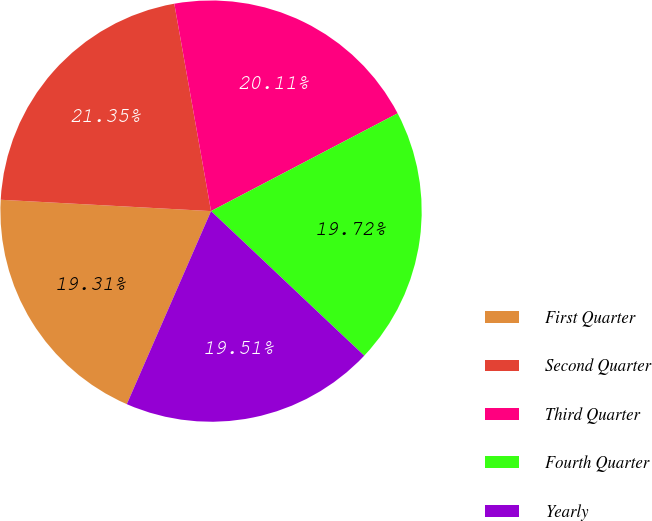Convert chart to OTSL. <chart><loc_0><loc_0><loc_500><loc_500><pie_chart><fcel>First Quarter<fcel>Second Quarter<fcel>Third Quarter<fcel>Fourth Quarter<fcel>Yearly<nl><fcel>19.31%<fcel>21.35%<fcel>20.11%<fcel>19.72%<fcel>19.51%<nl></chart> 